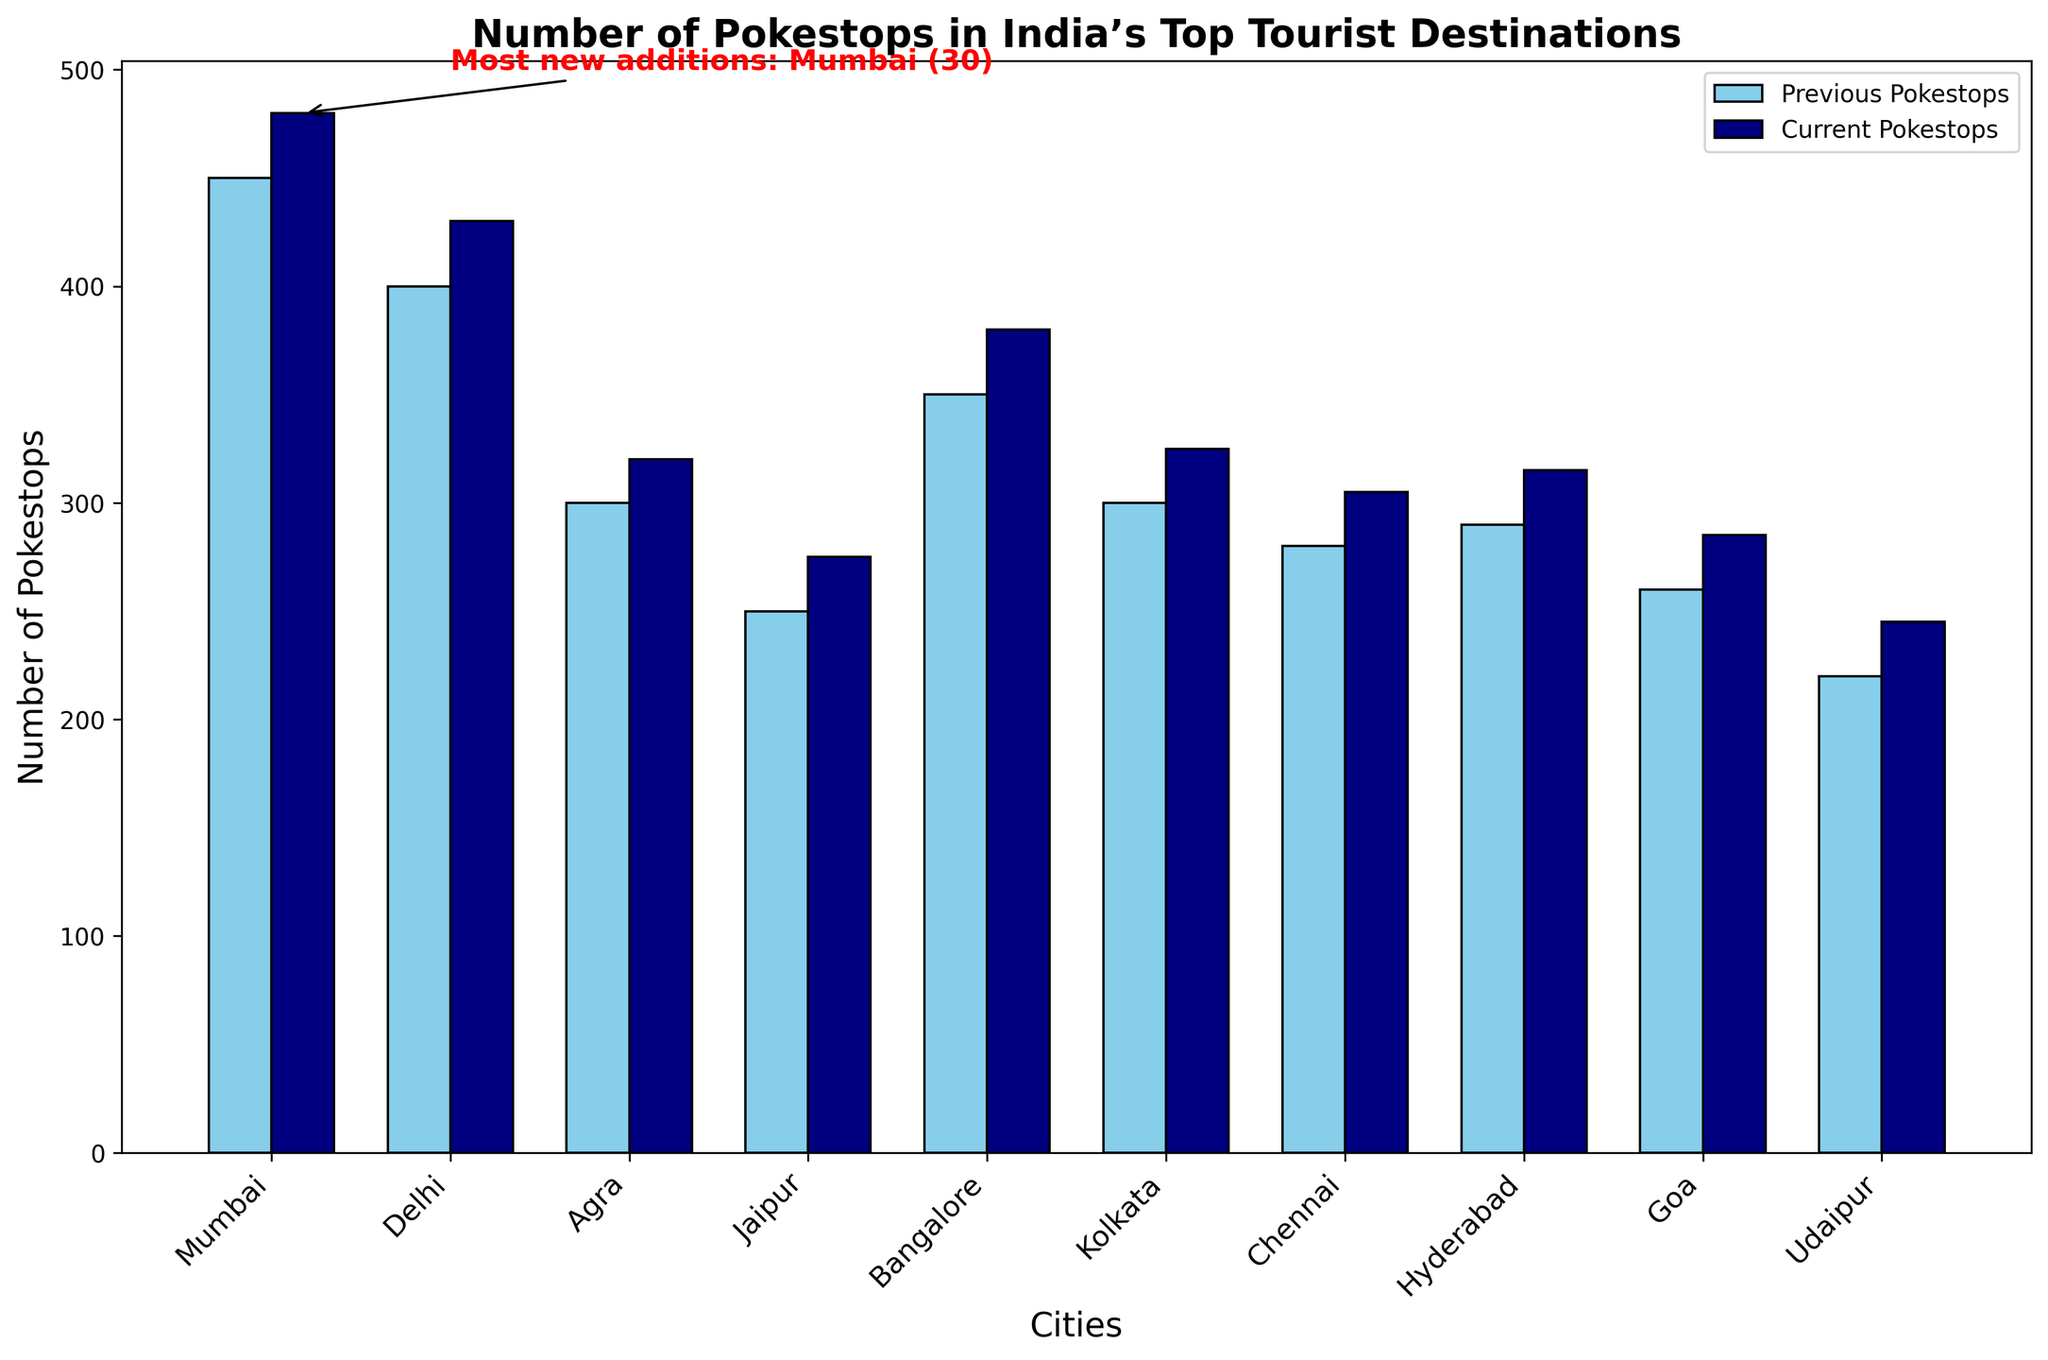Which city has the most new Pokestop additions? In the chart, an annotation points to one city with a text mentioning the most new additions, "Most new additions: Bangalore (30)", which marks Bangalore as having the highest number of new additions.
Answer: Bangalore How many more current Pokestops does Mumbai have compared to Agra? Looking at the bars for Mumbai and Agra, Mumbai has 480 current Pokestops, and Agra has 320. Calculating the difference, 480 - 320 = 160.
Answer: 160 What is the total number of new Pokestop additions across all cities? Sum the new additions from the data: 30 (Mumbai) + 30 (Delhi) + 20 (Agra) + 25 (Jaipur) + 30 (Bangalore) + 25 (Kolkata) + 25 (Chennai) + 25 (Hyderabad) + 25 (Goa) + 25 (Udaipur) = 260.
Answer: 260 Which city showed the smallest increase in the number of Pokestops? By comparing the new additions for each city, Agra has the smallest increase with 20 new additions, as highlighted in the data and chart.
Answer: Agra Between Chennai and Kolkata, which city has more current Pokestops, and by how much? Kolkata has 325 current Pokestops, and Chennai has 305. Calculating the difference, 325 - 305 = 20, so Kolkata has 20 more current Pokestops.
Answer: Kolkata by 20 What is the average number of previous Pokestops in these cities? Sum the previous Pokestops and divide by the number of cities: (450 + 400 + 300 + 250 + 350 + 300 + 280 + 290 + 260 + 220) / 10 = 3100 / 10 = 310.
Answer: 310 Which city has the second highest number of current Pokestops? By examining the height of the bars, the city with the second highest number of current Pokestops is Delhi with 430, just after Mumbai.
Answer: Delhi How many more previous Pokestops did Hyderabad have compared to Udaipur? Hyderabad had 290 previous Pokestops, and Udaipur had 220. The difference is 290 - 220 = 70.
Answer: 70 In which city did the number of Pokestops increase by 30? The cities with new additions of 30 are Mumbai, Delhi, and Bangalore, as indicated by their respective new additions data.
Answer: Mumbai, Delhi, Bangalore 